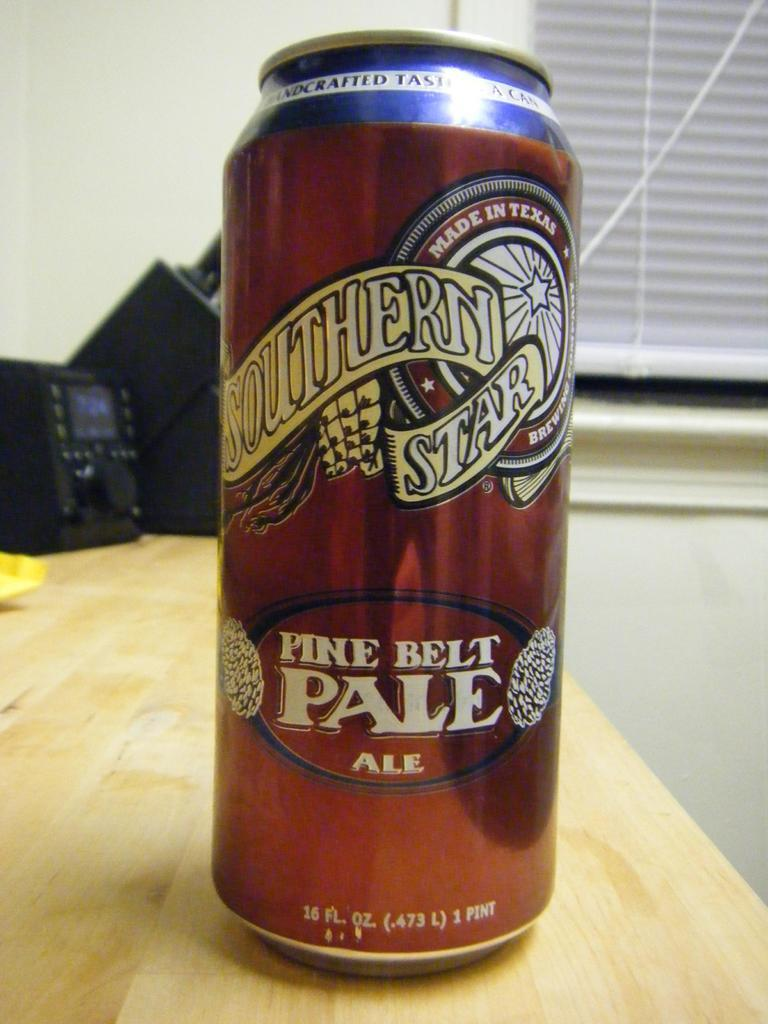Provide a one-sentence caption for the provided image. a aluminum can of southern star pine belt ale. 